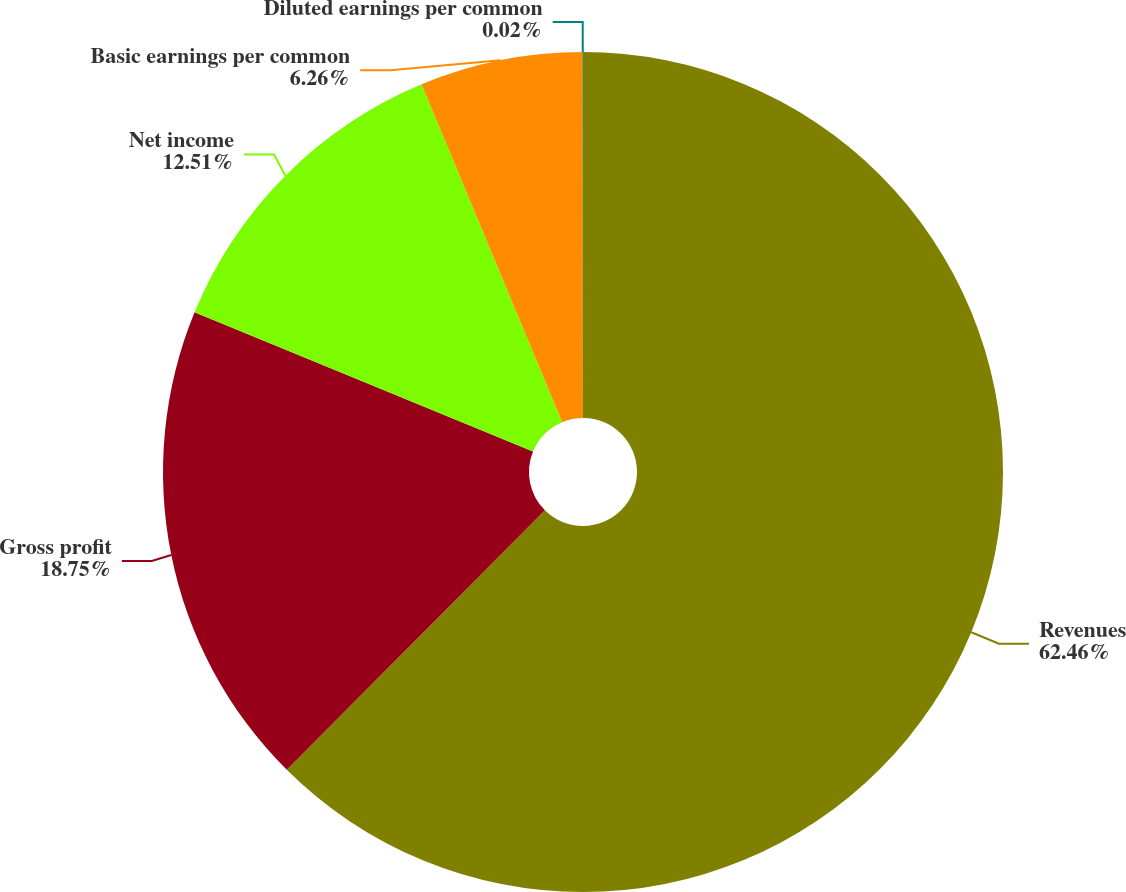Convert chart to OTSL. <chart><loc_0><loc_0><loc_500><loc_500><pie_chart><fcel>Revenues<fcel>Gross profit<fcel>Net income<fcel>Basic earnings per common<fcel>Diluted earnings per common<nl><fcel>62.46%<fcel>18.75%<fcel>12.51%<fcel>6.26%<fcel>0.02%<nl></chart> 